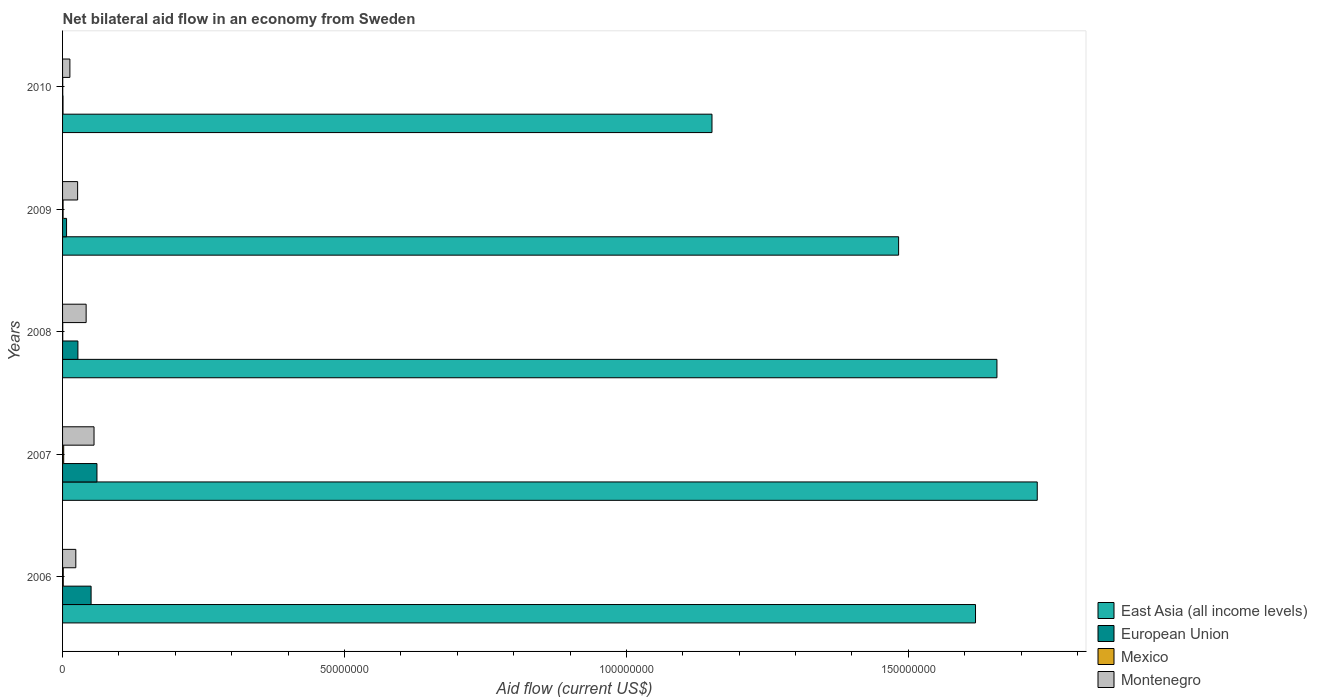How many different coloured bars are there?
Make the answer very short. 4. How many groups of bars are there?
Ensure brevity in your answer.  5. Are the number of bars per tick equal to the number of legend labels?
Keep it short and to the point. Yes. Are the number of bars on each tick of the Y-axis equal?
Your response must be concise. Yes. How many bars are there on the 4th tick from the top?
Your answer should be very brief. 4. How many bars are there on the 2nd tick from the bottom?
Your answer should be very brief. 4. What is the label of the 3rd group of bars from the top?
Offer a very short reply. 2008. Across all years, what is the maximum net bilateral aid flow in East Asia (all income levels)?
Your answer should be very brief. 1.73e+08. Across all years, what is the minimum net bilateral aid flow in East Asia (all income levels)?
Offer a very short reply. 1.15e+08. In which year was the net bilateral aid flow in Mexico maximum?
Offer a very short reply. 2007. What is the difference between the net bilateral aid flow in Montenegro in 2006 and that in 2008?
Your answer should be very brief. -1.83e+06. What is the difference between the net bilateral aid flow in Montenegro in 2008 and the net bilateral aid flow in European Union in 2007?
Your response must be concise. -1.92e+06. What is the average net bilateral aid flow in European Union per year?
Keep it short and to the point. 2.93e+06. In the year 2010, what is the difference between the net bilateral aid flow in East Asia (all income levels) and net bilateral aid flow in Montenegro?
Provide a short and direct response. 1.14e+08. In how many years, is the net bilateral aid flow in Mexico greater than 140000000 US$?
Give a very brief answer. 0. What is the ratio of the net bilateral aid flow in European Union in 2009 to that in 2010?
Provide a succinct answer. 8.88. What is the difference between the highest and the second highest net bilateral aid flow in Montenegro?
Ensure brevity in your answer.  1.40e+06. In how many years, is the net bilateral aid flow in European Union greater than the average net bilateral aid flow in European Union taken over all years?
Keep it short and to the point. 2. Is the sum of the net bilateral aid flow in East Asia (all income levels) in 2006 and 2009 greater than the maximum net bilateral aid flow in Montenegro across all years?
Give a very brief answer. Yes. Is it the case that in every year, the sum of the net bilateral aid flow in East Asia (all income levels) and net bilateral aid flow in European Union is greater than the sum of net bilateral aid flow in Montenegro and net bilateral aid flow in Mexico?
Your answer should be compact. Yes. What does the 4th bar from the top in 2006 represents?
Provide a succinct answer. East Asia (all income levels). What does the 2nd bar from the bottom in 2010 represents?
Give a very brief answer. European Union. Is it the case that in every year, the sum of the net bilateral aid flow in European Union and net bilateral aid flow in East Asia (all income levels) is greater than the net bilateral aid flow in Mexico?
Your answer should be compact. Yes. How many bars are there?
Ensure brevity in your answer.  20. What is the difference between two consecutive major ticks on the X-axis?
Provide a short and direct response. 5.00e+07. Does the graph contain grids?
Your response must be concise. No. Where does the legend appear in the graph?
Give a very brief answer. Bottom right. How are the legend labels stacked?
Give a very brief answer. Vertical. What is the title of the graph?
Keep it short and to the point. Net bilateral aid flow in an economy from Sweden. Does "Philippines" appear as one of the legend labels in the graph?
Provide a short and direct response. No. What is the Aid flow (current US$) of East Asia (all income levels) in 2006?
Give a very brief answer. 1.62e+08. What is the Aid flow (current US$) of European Union in 2006?
Your answer should be compact. 5.06e+06. What is the Aid flow (current US$) in Mexico in 2006?
Offer a terse response. 1.20e+05. What is the Aid flow (current US$) in Montenegro in 2006?
Give a very brief answer. 2.35e+06. What is the Aid flow (current US$) in East Asia (all income levels) in 2007?
Ensure brevity in your answer.  1.73e+08. What is the Aid flow (current US$) of European Union in 2007?
Keep it short and to the point. 6.10e+06. What is the Aid flow (current US$) in Montenegro in 2007?
Offer a very short reply. 5.58e+06. What is the Aid flow (current US$) in East Asia (all income levels) in 2008?
Your answer should be very brief. 1.66e+08. What is the Aid flow (current US$) in European Union in 2008?
Keep it short and to the point. 2.72e+06. What is the Aid flow (current US$) of Mexico in 2008?
Your response must be concise. 3.00e+04. What is the Aid flow (current US$) in Montenegro in 2008?
Your response must be concise. 4.18e+06. What is the Aid flow (current US$) in East Asia (all income levels) in 2009?
Provide a short and direct response. 1.48e+08. What is the Aid flow (current US$) in European Union in 2009?
Offer a terse response. 7.10e+05. What is the Aid flow (current US$) in Mexico in 2009?
Your answer should be very brief. 9.00e+04. What is the Aid flow (current US$) of Montenegro in 2009?
Your answer should be compact. 2.67e+06. What is the Aid flow (current US$) in East Asia (all income levels) in 2010?
Your response must be concise. 1.15e+08. What is the Aid flow (current US$) of Mexico in 2010?
Ensure brevity in your answer.  3.00e+04. What is the Aid flow (current US$) of Montenegro in 2010?
Offer a terse response. 1.30e+06. Across all years, what is the maximum Aid flow (current US$) of East Asia (all income levels)?
Give a very brief answer. 1.73e+08. Across all years, what is the maximum Aid flow (current US$) in European Union?
Offer a terse response. 6.10e+06. Across all years, what is the maximum Aid flow (current US$) in Mexico?
Offer a very short reply. 2.00e+05. Across all years, what is the maximum Aid flow (current US$) of Montenegro?
Provide a succinct answer. 5.58e+06. Across all years, what is the minimum Aid flow (current US$) in East Asia (all income levels)?
Provide a succinct answer. 1.15e+08. Across all years, what is the minimum Aid flow (current US$) in European Union?
Your answer should be very brief. 8.00e+04. Across all years, what is the minimum Aid flow (current US$) in Mexico?
Provide a succinct answer. 3.00e+04. Across all years, what is the minimum Aid flow (current US$) in Montenegro?
Your response must be concise. 1.30e+06. What is the total Aid flow (current US$) of East Asia (all income levels) in the graph?
Offer a very short reply. 7.64e+08. What is the total Aid flow (current US$) in European Union in the graph?
Provide a short and direct response. 1.47e+07. What is the total Aid flow (current US$) of Montenegro in the graph?
Give a very brief answer. 1.61e+07. What is the difference between the Aid flow (current US$) in East Asia (all income levels) in 2006 and that in 2007?
Offer a terse response. -1.10e+07. What is the difference between the Aid flow (current US$) in European Union in 2006 and that in 2007?
Your answer should be compact. -1.04e+06. What is the difference between the Aid flow (current US$) in Mexico in 2006 and that in 2007?
Ensure brevity in your answer.  -8.00e+04. What is the difference between the Aid flow (current US$) in Montenegro in 2006 and that in 2007?
Make the answer very short. -3.23e+06. What is the difference between the Aid flow (current US$) of East Asia (all income levels) in 2006 and that in 2008?
Ensure brevity in your answer.  -3.80e+06. What is the difference between the Aid flow (current US$) of European Union in 2006 and that in 2008?
Keep it short and to the point. 2.34e+06. What is the difference between the Aid flow (current US$) in Montenegro in 2006 and that in 2008?
Offer a terse response. -1.83e+06. What is the difference between the Aid flow (current US$) of East Asia (all income levels) in 2006 and that in 2009?
Ensure brevity in your answer.  1.36e+07. What is the difference between the Aid flow (current US$) in European Union in 2006 and that in 2009?
Offer a very short reply. 4.35e+06. What is the difference between the Aid flow (current US$) in Mexico in 2006 and that in 2009?
Keep it short and to the point. 3.00e+04. What is the difference between the Aid flow (current US$) in Montenegro in 2006 and that in 2009?
Offer a terse response. -3.20e+05. What is the difference between the Aid flow (current US$) in East Asia (all income levels) in 2006 and that in 2010?
Ensure brevity in your answer.  4.67e+07. What is the difference between the Aid flow (current US$) of European Union in 2006 and that in 2010?
Offer a very short reply. 4.98e+06. What is the difference between the Aid flow (current US$) of Montenegro in 2006 and that in 2010?
Provide a succinct answer. 1.05e+06. What is the difference between the Aid flow (current US$) of East Asia (all income levels) in 2007 and that in 2008?
Offer a very short reply. 7.15e+06. What is the difference between the Aid flow (current US$) of European Union in 2007 and that in 2008?
Offer a very short reply. 3.38e+06. What is the difference between the Aid flow (current US$) of Montenegro in 2007 and that in 2008?
Provide a succinct answer. 1.40e+06. What is the difference between the Aid flow (current US$) of East Asia (all income levels) in 2007 and that in 2009?
Ensure brevity in your answer.  2.46e+07. What is the difference between the Aid flow (current US$) of European Union in 2007 and that in 2009?
Your answer should be compact. 5.39e+06. What is the difference between the Aid flow (current US$) in Montenegro in 2007 and that in 2009?
Your answer should be compact. 2.91e+06. What is the difference between the Aid flow (current US$) in East Asia (all income levels) in 2007 and that in 2010?
Provide a short and direct response. 5.77e+07. What is the difference between the Aid flow (current US$) in European Union in 2007 and that in 2010?
Provide a short and direct response. 6.02e+06. What is the difference between the Aid flow (current US$) of Montenegro in 2007 and that in 2010?
Offer a very short reply. 4.28e+06. What is the difference between the Aid flow (current US$) in East Asia (all income levels) in 2008 and that in 2009?
Your answer should be very brief. 1.74e+07. What is the difference between the Aid flow (current US$) in European Union in 2008 and that in 2009?
Your answer should be compact. 2.01e+06. What is the difference between the Aid flow (current US$) in Montenegro in 2008 and that in 2009?
Your response must be concise. 1.51e+06. What is the difference between the Aid flow (current US$) of East Asia (all income levels) in 2008 and that in 2010?
Your answer should be compact. 5.05e+07. What is the difference between the Aid flow (current US$) of European Union in 2008 and that in 2010?
Offer a terse response. 2.64e+06. What is the difference between the Aid flow (current US$) in Mexico in 2008 and that in 2010?
Keep it short and to the point. 0. What is the difference between the Aid flow (current US$) of Montenegro in 2008 and that in 2010?
Your answer should be very brief. 2.88e+06. What is the difference between the Aid flow (current US$) in East Asia (all income levels) in 2009 and that in 2010?
Your answer should be very brief. 3.31e+07. What is the difference between the Aid flow (current US$) in European Union in 2009 and that in 2010?
Ensure brevity in your answer.  6.30e+05. What is the difference between the Aid flow (current US$) of Mexico in 2009 and that in 2010?
Offer a terse response. 6.00e+04. What is the difference between the Aid flow (current US$) of Montenegro in 2009 and that in 2010?
Offer a very short reply. 1.37e+06. What is the difference between the Aid flow (current US$) in East Asia (all income levels) in 2006 and the Aid flow (current US$) in European Union in 2007?
Give a very brief answer. 1.56e+08. What is the difference between the Aid flow (current US$) in East Asia (all income levels) in 2006 and the Aid flow (current US$) in Mexico in 2007?
Provide a short and direct response. 1.62e+08. What is the difference between the Aid flow (current US$) in East Asia (all income levels) in 2006 and the Aid flow (current US$) in Montenegro in 2007?
Your response must be concise. 1.56e+08. What is the difference between the Aid flow (current US$) in European Union in 2006 and the Aid flow (current US$) in Mexico in 2007?
Give a very brief answer. 4.86e+06. What is the difference between the Aid flow (current US$) of European Union in 2006 and the Aid flow (current US$) of Montenegro in 2007?
Your answer should be very brief. -5.20e+05. What is the difference between the Aid flow (current US$) in Mexico in 2006 and the Aid flow (current US$) in Montenegro in 2007?
Provide a succinct answer. -5.46e+06. What is the difference between the Aid flow (current US$) of East Asia (all income levels) in 2006 and the Aid flow (current US$) of European Union in 2008?
Offer a terse response. 1.59e+08. What is the difference between the Aid flow (current US$) in East Asia (all income levels) in 2006 and the Aid flow (current US$) in Mexico in 2008?
Provide a short and direct response. 1.62e+08. What is the difference between the Aid flow (current US$) in East Asia (all income levels) in 2006 and the Aid flow (current US$) in Montenegro in 2008?
Offer a very short reply. 1.58e+08. What is the difference between the Aid flow (current US$) in European Union in 2006 and the Aid flow (current US$) in Mexico in 2008?
Keep it short and to the point. 5.03e+06. What is the difference between the Aid flow (current US$) in European Union in 2006 and the Aid flow (current US$) in Montenegro in 2008?
Provide a succinct answer. 8.80e+05. What is the difference between the Aid flow (current US$) in Mexico in 2006 and the Aid flow (current US$) in Montenegro in 2008?
Keep it short and to the point. -4.06e+06. What is the difference between the Aid flow (current US$) of East Asia (all income levels) in 2006 and the Aid flow (current US$) of European Union in 2009?
Keep it short and to the point. 1.61e+08. What is the difference between the Aid flow (current US$) of East Asia (all income levels) in 2006 and the Aid flow (current US$) of Mexico in 2009?
Your answer should be very brief. 1.62e+08. What is the difference between the Aid flow (current US$) of East Asia (all income levels) in 2006 and the Aid flow (current US$) of Montenegro in 2009?
Your answer should be very brief. 1.59e+08. What is the difference between the Aid flow (current US$) in European Union in 2006 and the Aid flow (current US$) in Mexico in 2009?
Keep it short and to the point. 4.97e+06. What is the difference between the Aid flow (current US$) of European Union in 2006 and the Aid flow (current US$) of Montenegro in 2009?
Make the answer very short. 2.39e+06. What is the difference between the Aid flow (current US$) in Mexico in 2006 and the Aid flow (current US$) in Montenegro in 2009?
Your answer should be compact. -2.55e+06. What is the difference between the Aid flow (current US$) of East Asia (all income levels) in 2006 and the Aid flow (current US$) of European Union in 2010?
Your answer should be compact. 1.62e+08. What is the difference between the Aid flow (current US$) of East Asia (all income levels) in 2006 and the Aid flow (current US$) of Mexico in 2010?
Provide a short and direct response. 1.62e+08. What is the difference between the Aid flow (current US$) in East Asia (all income levels) in 2006 and the Aid flow (current US$) in Montenegro in 2010?
Offer a terse response. 1.61e+08. What is the difference between the Aid flow (current US$) of European Union in 2006 and the Aid flow (current US$) of Mexico in 2010?
Your response must be concise. 5.03e+06. What is the difference between the Aid flow (current US$) in European Union in 2006 and the Aid flow (current US$) in Montenegro in 2010?
Provide a short and direct response. 3.76e+06. What is the difference between the Aid flow (current US$) of Mexico in 2006 and the Aid flow (current US$) of Montenegro in 2010?
Your answer should be compact. -1.18e+06. What is the difference between the Aid flow (current US$) of East Asia (all income levels) in 2007 and the Aid flow (current US$) of European Union in 2008?
Keep it short and to the point. 1.70e+08. What is the difference between the Aid flow (current US$) in East Asia (all income levels) in 2007 and the Aid flow (current US$) in Mexico in 2008?
Provide a short and direct response. 1.73e+08. What is the difference between the Aid flow (current US$) in East Asia (all income levels) in 2007 and the Aid flow (current US$) in Montenegro in 2008?
Ensure brevity in your answer.  1.69e+08. What is the difference between the Aid flow (current US$) in European Union in 2007 and the Aid flow (current US$) in Mexico in 2008?
Keep it short and to the point. 6.07e+06. What is the difference between the Aid flow (current US$) of European Union in 2007 and the Aid flow (current US$) of Montenegro in 2008?
Make the answer very short. 1.92e+06. What is the difference between the Aid flow (current US$) in Mexico in 2007 and the Aid flow (current US$) in Montenegro in 2008?
Provide a succinct answer. -3.98e+06. What is the difference between the Aid flow (current US$) of East Asia (all income levels) in 2007 and the Aid flow (current US$) of European Union in 2009?
Your response must be concise. 1.72e+08. What is the difference between the Aid flow (current US$) in East Asia (all income levels) in 2007 and the Aid flow (current US$) in Mexico in 2009?
Provide a short and direct response. 1.73e+08. What is the difference between the Aid flow (current US$) in East Asia (all income levels) in 2007 and the Aid flow (current US$) in Montenegro in 2009?
Provide a succinct answer. 1.70e+08. What is the difference between the Aid flow (current US$) of European Union in 2007 and the Aid flow (current US$) of Mexico in 2009?
Your answer should be very brief. 6.01e+06. What is the difference between the Aid flow (current US$) in European Union in 2007 and the Aid flow (current US$) in Montenegro in 2009?
Ensure brevity in your answer.  3.43e+06. What is the difference between the Aid flow (current US$) of Mexico in 2007 and the Aid flow (current US$) of Montenegro in 2009?
Offer a very short reply. -2.47e+06. What is the difference between the Aid flow (current US$) in East Asia (all income levels) in 2007 and the Aid flow (current US$) in European Union in 2010?
Provide a succinct answer. 1.73e+08. What is the difference between the Aid flow (current US$) in East Asia (all income levels) in 2007 and the Aid flow (current US$) in Mexico in 2010?
Offer a terse response. 1.73e+08. What is the difference between the Aid flow (current US$) in East Asia (all income levels) in 2007 and the Aid flow (current US$) in Montenegro in 2010?
Keep it short and to the point. 1.72e+08. What is the difference between the Aid flow (current US$) of European Union in 2007 and the Aid flow (current US$) of Mexico in 2010?
Your answer should be compact. 6.07e+06. What is the difference between the Aid flow (current US$) of European Union in 2007 and the Aid flow (current US$) of Montenegro in 2010?
Provide a short and direct response. 4.80e+06. What is the difference between the Aid flow (current US$) of Mexico in 2007 and the Aid flow (current US$) of Montenegro in 2010?
Provide a succinct answer. -1.10e+06. What is the difference between the Aid flow (current US$) of East Asia (all income levels) in 2008 and the Aid flow (current US$) of European Union in 2009?
Keep it short and to the point. 1.65e+08. What is the difference between the Aid flow (current US$) of East Asia (all income levels) in 2008 and the Aid flow (current US$) of Mexico in 2009?
Offer a very short reply. 1.66e+08. What is the difference between the Aid flow (current US$) in East Asia (all income levels) in 2008 and the Aid flow (current US$) in Montenegro in 2009?
Make the answer very short. 1.63e+08. What is the difference between the Aid flow (current US$) of European Union in 2008 and the Aid flow (current US$) of Mexico in 2009?
Provide a short and direct response. 2.63e+06. What is the difference between the Aid flow (current US$) of Mexico in 2008 and the Aid flow (current US$) of Montenegro in 2009?
Your response must be concise. -2.64e+06. What is the difference between the Aid flow (current US$) of East Asia (all income levels) in 2008 and the Aid flow (current US$) of European Union in 2010?
Your answer should be very brief. 1.66e+08. What is the difference between the Aid flow (current US$) of East Asia (all income levels) in 2008 and the Aid flow (current US$) of Mexico in 2010?
Give a very brief answer. 1.66e+08. What is the difference between the Aid flow (current US$) in East Asia (all income levels) in 2008 and the Aid flow (current US$) in Montenegro in 2010?
Make the answer very short. 1.64e+08. What is the difference between the Aid flow (current US$) of European Union in 2008 and the Aid flow (current US$) of Mexico in 2010?
Provide a short and direct response. 2.69e+06. What is the difference between the Aid flow (current US$) of European Union in 2008 and the Aid flow (current US$) of Montenegro in 2010?
Your response must be concise. 1.42e+06. What is the difference between the Aid flow (current US$) in Mexico in 2008 and the Aid flow (current US$) in Montenegro in 2010?
Offer a terse response. -1.27e+06. What is the difference between the Aid flow (current US$) of East Asia (all income levels) in 2009 and the Aid flow (current US$) of European Union in 2010?
Provide a succinct answer. 1.48e+08. What is the difference between the Aid flow (current US$) of East Asia (all income levels) in 2009 and the Aid flow (current US$) of Mexico in 2010?
Ensure brevity in your answer.  1.48e+08. What is the difference between the Aid flow (current US$) in East Asia (all income levels) in 2009 and the Aid flow (current US$) in Montenegro in 2010?
Ensure brevity in your answer.  1.47e+08. What is the difference between the Aid flow (current US$) in European Union in 2009 and the Aid flow (current US$) in Mexico in 2010?
Keep it short and to the point. 6.80e+05. What is the difference between the Aid flow (current US$) of European Union in 2009 and the Aid flow (current US$) of Montenegro in 2010?
Provide a succinct answer. -5.90e+05. What is the difference between the Aid flow (current US$) of Mexico in 2009 and the Aid flow (current US$) of Montenegro in 2010?
Offer a terse response. -1.21e+06. What is the average Aid flow (current US$) in East Asia (all income levels) per year?
Give a very brief answer. 1.53e+08. What is the average Aid flow (current US$) in European Union per year?
Ensure brevity in your answer.  2.93e+06. What is the average Aid flow (current US$) in Mexico per year?
Provide a short and direct response. 9.40e+04. What is the average Aid flow (current US$) of Montenegro per year?
Offer a terse response. 3.22e+06. In the year 2006, what is the difference between the Aid flow (current US$) in East Asia (all income levels) and Aid flow (current US$) in European Union?
Ensure brevity in your answer.  1.57e+08. In the year 2006, what is the difference between the Aid flow (current US$) in East Asia (all income levels) and Aid flow (current US$) in Mexico?
Ensure brevity in your answer.  1.62e+08. In the year 2006, what is the difference between the Aid flow (current US$) in East Asia (all income levels) and Aid flow (current US$) in Montenegro?
Make the answer very short. 1.60e+08. In the year 2006, what is the difference between the Aid flow (current US$) of European Union and Aid flow (current US$) of Mexico?
Make the answer very short. 4.94e+06. In the year 2006, what is the difference between the Aid flow (current US$) in European Union and Aid flow (current US$) in Montenegro?
Make the answer very short. 2.71e+06. In the year 2006, what is the difference between the Aid flow (current US$) in Mexico and Aid flow (current US$) in Montenegro?
Provide a short and direct response. -2.23e+06. In the year 2007, what is the difference between the Aid flow (current US$) in East Asia (all income levels) and Aid flow (current US$) in European Union?
Offer a terse response. 1.67e+08. In the year 2007, what is the difference between the Aid flow (current US$) in East Asia (all income levels) and Aid flow (current US$) in Mexico?
Keep it short and to the point. 1.73e+08. In the year 2007, what is the difference between the Aid flow (current US$) in East Asia (all income levels) and Aid flow (current US$) in Montenegro?
Your response must be concise. 1.67e+08. In the year 2007, what is the difference between the Aid flow (current US$) in European Union and Aid flow (current US$) in Mexico?
Give a very brief answer. 5.90e+06. In the year 2007, what is the difference between the Aid flow (current US$) in European Union and Aid flow (current US$) in Montenegro?
Offer a terse response. 5.20e+05. In the year 2007, what is the difference between the Aid flow (current US$) in Mexico and Aid flow (current US$) in Montenegro?
Provide a short and direct response. -5.38e+06. In the year 2008, what is the difference between the Aid flow (current US$) in East Asia (all income levels) and Aid flow (current US$) in European Union?
Your response must be concise. 1.63e+08. In the year 2008, what is the difference between the Aid flow (current US$) in East Asia (all income levels) and Aid flow (current US$) in Mexico?
Provide a succinct answer. 1.66e+08. In the year 2008, what is the difference between the Aid flow (current US$) in East Asia (all income levels) and Aid flow (current US$) in Montenegro?
Offer a terse response. 1.62e+08. In the year 2008, what is the difference between the Aid flow (current US$) of European Union and Aid flow (current US$) of Mexico?
Your response must be concise. 2.69e+06. In the year 2008, what is the difference between the Aid flow (current US$) in European Union and Aid flow (current US$) in Montenegro?
Your answer should be very brief. -1.46e+06. In the year 2008, what is the difference between the Aid flow (current US$) in Mexico and Aid flow (current US$) in Montenegro?
Ensure brevity in your answer.  -4.15e+06. In the year 2009, what is the difference between the Aid flow (current US$) of East Asia (all income levels) and Aid flow (current US$) of European Union?
Give a very brief answer. 1.48e+08. In the year 2009, what is the difference between the Aid flow (current US$) of East Asia (all income levels) and Aid flow (current US$) of Mexico?
Ensure brevity in your answer.  1.48e+08. In the year 2009, what is the difference between the Aid flow (current US$) of East Asia (all income levels) and Aid flow (current US$) of Montenegro?
Offer a very short reply. 1.46e+08. In the year 2009, what is the difference between the Aid flow (current US$) in European Union and Aid flow (current US$) in Mexico?
Make the answer very short. 6.20e+05. In the year 2009, what is the difference between the Aid flow (current US$) in European Union and Aid flow (current US$) in Montenegro?
Ensure brevity in your answer.  -1.96e+06. In the year 2009, what is the difference between the Aid flow (current US$) in Mexico and Aid flow (current US$) in Montenegro?
Give a very brief answer. -2.58e+06. In the year 2010, what is the difference between the Aid flow (current US$) in East Asia (all income levels) and Aid flow (current US$) in European Union?
Make the answer very short. 1.15e+08. In the year 2010, what is the difference between the Aid flow (current US$) in East Asia (all income levels) and Aid flow (current US$) in Mexico?
Your response must be concise. 1.15e+08. In the year 2010, what is the difference between the Aid flow (current US$) of East Asia (all income levels) and Aid flow (current US$) of Montenegro?
Keep it short and to the point. 1.14e+08. In the year 2010, what is the difference between the Aid flow (current US$) in European Union and Aid flow (current US$) in Mexico?
Offer a very short reply. 5.00e+04. In the year 2010, what is the difference between the Aid flow (current US$) in European Union and Aid flow (current US$) in Montenegro?
Keep it short and to the point. -1.22e+06. In the year 2010, what is the difference between the Aid flow (current US$) in Mexico and Aid flow (current US$) in Montenegro?
Make the answer very short. -1.27e+06. What is the ratio of the Aid flow (current US$) in East Asia (all income levels) in 2006 to that in 2007?
Offer a terse response. 0.94. What is the ratio of the Aid flow (current US$) of European Union in 2006 to that in 2007?
Offer a terse response. 0.83. What is the ratio of the Aid flow (current US$) of Mexico in 2006 to that in 2007?
Your answer should be very brief. 0.6. What is the ratio of the Aid flow (current US$) in Montenegro in 2006 to that in 2007?
Ensure brevity in your answer.  0.42. What is the ratio of the Aid flow (current US$) of East Asia (all income levels) in 2006 to that in 2008?
Your answer should be very brief. 0.98. What is the ratio of the Aid flow (current US$) of European Union in 2006 to that in 2008?
Ensure brevity in your answer.  1.86. What is the ratio of the Aid flow (current US$) of Mexico in 2006 to that in 2008?
Your answer should be very brief. 4. What is the ratio of the Aid flow (current US$) of Montenegro in 2006 to that in 2008?
Ensure brevity in your answer.  0.56. What is the ratio of the Aid flow (current US$) of East Asia (all income levels) in 2006 to that in 2009?
Keep it short and to the point. 1.09. What is the ratio of the Aid flow (current US$) of European Union in 2006 to that in 2009?
Make the answer very short. 7.13. What is the ratio of the Aid flow (current US$) in Montenegro in 2006 to that in 2009?
Your response must be concise. 0.88. What is the ratio of the Aid flow (current US$) in East Asia (all income levels) in 2006 to that in 2010?
Make the answer very short. 1.41. What is the ratio of the Aid flow (current US$) of European Union in 2006 to that in 2010?
Ensure brevity in your answer.  63.25. What is the ratio of the Aid flow (current US$) of Mexico in 2006 to that in 2010?
Provide a short and direct response. 4. What is the ratio of the Aid flow (current US$) of Montenegro in 2006 to that in 2010?
Keep it short and to the point. 1.81. What is the ratio of the Aid flow (current US$) of East Asia (all income levels) in 2007 to that in 2008?
Offer a very short reply. 1.04. What is the ratio of the Aid flow (current US$) in European Union in 2007 to that in 2008?
Your answer should be very brief. 2.24. What is the ratio of the Aid flow (current US$) of Mexico in 2007 to that in 2008?
Ensure brevity in your answer.  6.67. What is the ratio of the Aid flow (current US$) in Montenegro in 2007 to that in 2008?
Your answer should be compact. 1.33. What is the ratio of the Aid flow (current US$) of East Asia (all income levels) in 2007 to that in 2009?
Offer a very short reply. 1.17. What is the ratio of the Aid flow (current US$) of European Union in 2007 to that in 2009?
Give a very brief answer. 8.59. What is the ratio of the Aid flow (current US$) of Mexico in 2007 to that in 2009?
Make the answer very short. 2.22. What is the ratio of the Aid flow (current US$) of Montenegro in 2007 to that in 2009?
Your answer should be very brief. 2.09. What is the ratio of the Aid flow (current US$) of East Asia (all income levels) in 2007 to that in 2010?
Provide a short and direct response. 1.5. What is the ratio of the Aid flow (current US$) in European Union in 2007 to that in 2010?
Make the answer very short. 76.25. What is the ratio of the Aid flow (current US$) in Mexico in 2007 to that in 2010?
Your answer should be compact. 6.67. What is the ratio of the Aid flow (current US$) in Montenegro in 2007 to that in 2010?
Your answer should be compact. 4.29. What is the ratio of the Aid flow (current US$) of East Asia (all income levels) in 2008 to that in 2009?
Keep it short and to the point. 1.12. What is the ratio of the Aid flow (current US$) in European Union in 2008 to that in 2009?
Provide a succinct answer. 3.83. What is the ratio of the Aid flow (current US$) of Montenegro in 2008 to that in 2009?
Ensure brevity in your answer.  1.57. What is the ratio of the Aid flow (current US$) of East Asia (all income levels) in 2008 to that in 2010?
Keep it short and to the point. 1.44. What is the ratio of the Aid flow (current US$) of Montenegro in 2008 to that in 2010?
Ensure brevity in your answer.  3.22. What is the ratio of the Aid flow (current US$) of East Asia (all income levels) in 2009 to that in 2010?
Give a very brief answer. 1.29. What is the ratio of the Aid flow (current US$) in European Union in 2009 to that in 2010?
Make the answer very short. 8.88. What is the ratio of the Aid flow (current US$) in Montenegro in 2009 to that in 2010?
Offer a terse response. 2.05. What is the difference between the highest and the second highest Aid flow (current US$) of East Asia (all income levels)?
Offer a very short reply. 7.15e+06. What is the difference between the highest and the second highest Aid flow (current US$) of European Union?
Provide a short and direct response. 1.04e+06. What is the difference between the highest and the second highest Aid flow (current US$) in Montenegro?
Give a very brief answer. 1.40e+06. What is the difference between the highest and the lowest Aid flow (current US$) in East Asia (all income levels)?
Your answer should be very brief. 5.77e+07. What is the difference between the highest and the lowest Aid flow (current US$) of European Union?
Provide a succinct answer. 6.02e+06. What is the difference between the highest and the lowest Aid flow (current US$) of Mexico?
Offer a terse response. 1.70e+05. What is the difference between the highest and the lowest Aid flow (current US$) in Montenegro?
Give a very brief answer. 4.28e+06. 